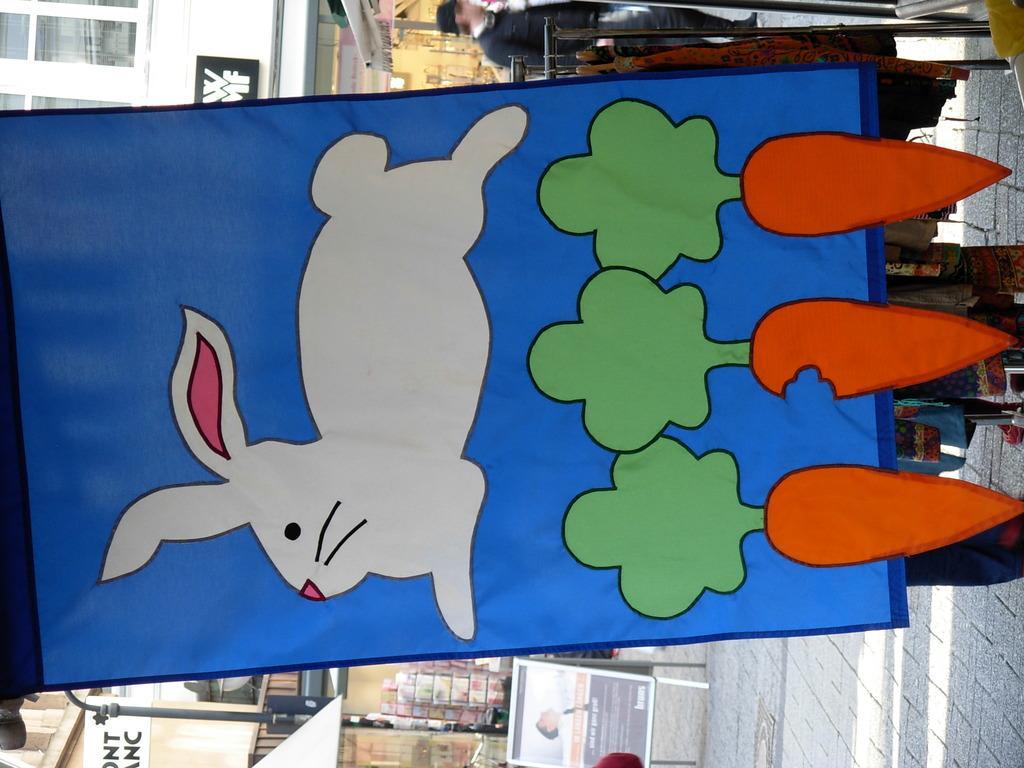What is featured on the banner in the image? The banner has pictures of a rabbit and carrots. What can be seen in the background of the image? There is a building and a pole in the background of the image. Can you describe the building? The building has windows. Is there anyone present in the image? Yes, a person is standing on the right side of the image. How much debt is the rabbit in the image facing? There is no indication of debt in the image, as it features a banner with pictures of a rabbit and carrots. 